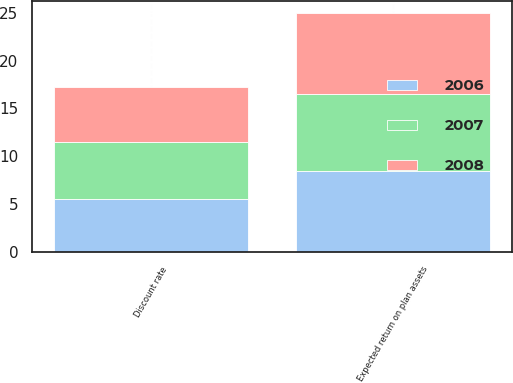Convert chart to OTSL. <chart><loc_0><loc_0><loc_500><loc_500><stacked_bar_chart><ecel><fcel>Discount rate<fcel>Expected return on plan assets<nl><fcel>2007<fcel>6<fcel>8<nl><fcel>2008<fcel>5.75<fcel>8.5<nl><fcel>2006<fcel>5.5<fcel>8.5<nl></chart> 